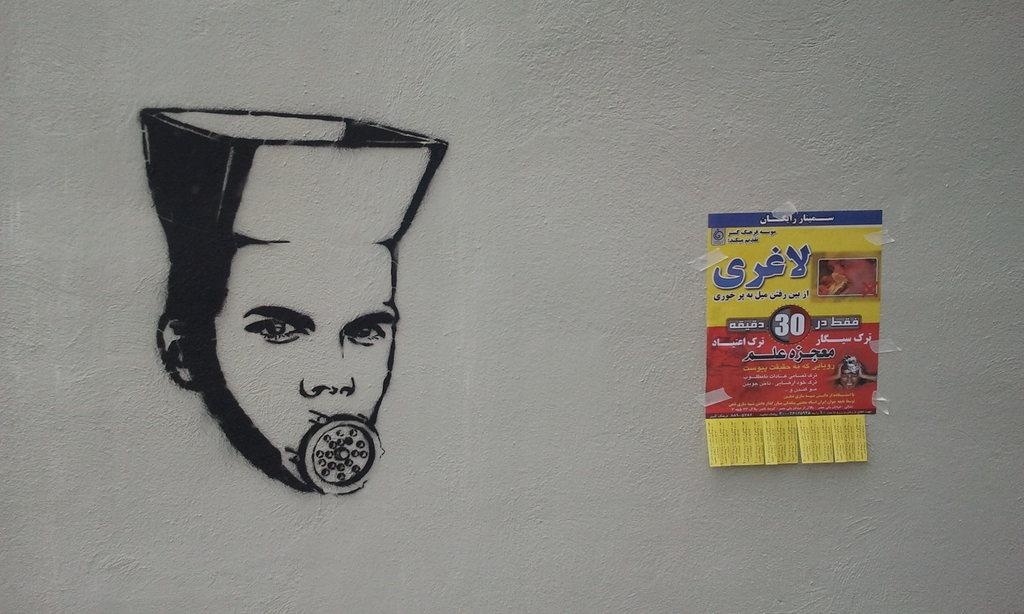What is the main subject of the painting in the image? There is a person's painting in the image. What else can be seen in the image besides the painting? There is a poster attached to the wall in the image. How many boys are wearing coats in the image? There are no boys or coats present in the image. 